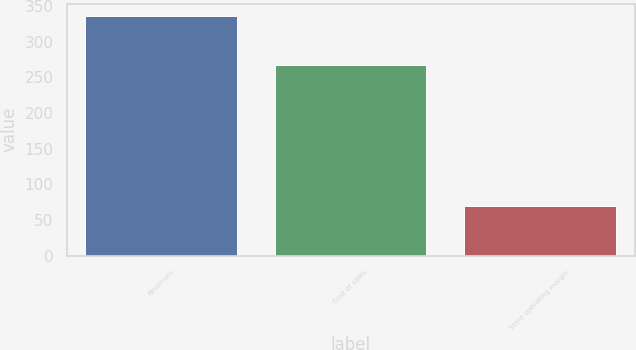Convert chart to OTSL. <chart><loc_0><loc_0><loc_500><loc_500><bar_chart><fcel>Revenues<fcel>Cost of sales<fcel>Store operating margin<nl><fcel>336.3<fcel>267.1<fcel>69.3<nl></chart> 